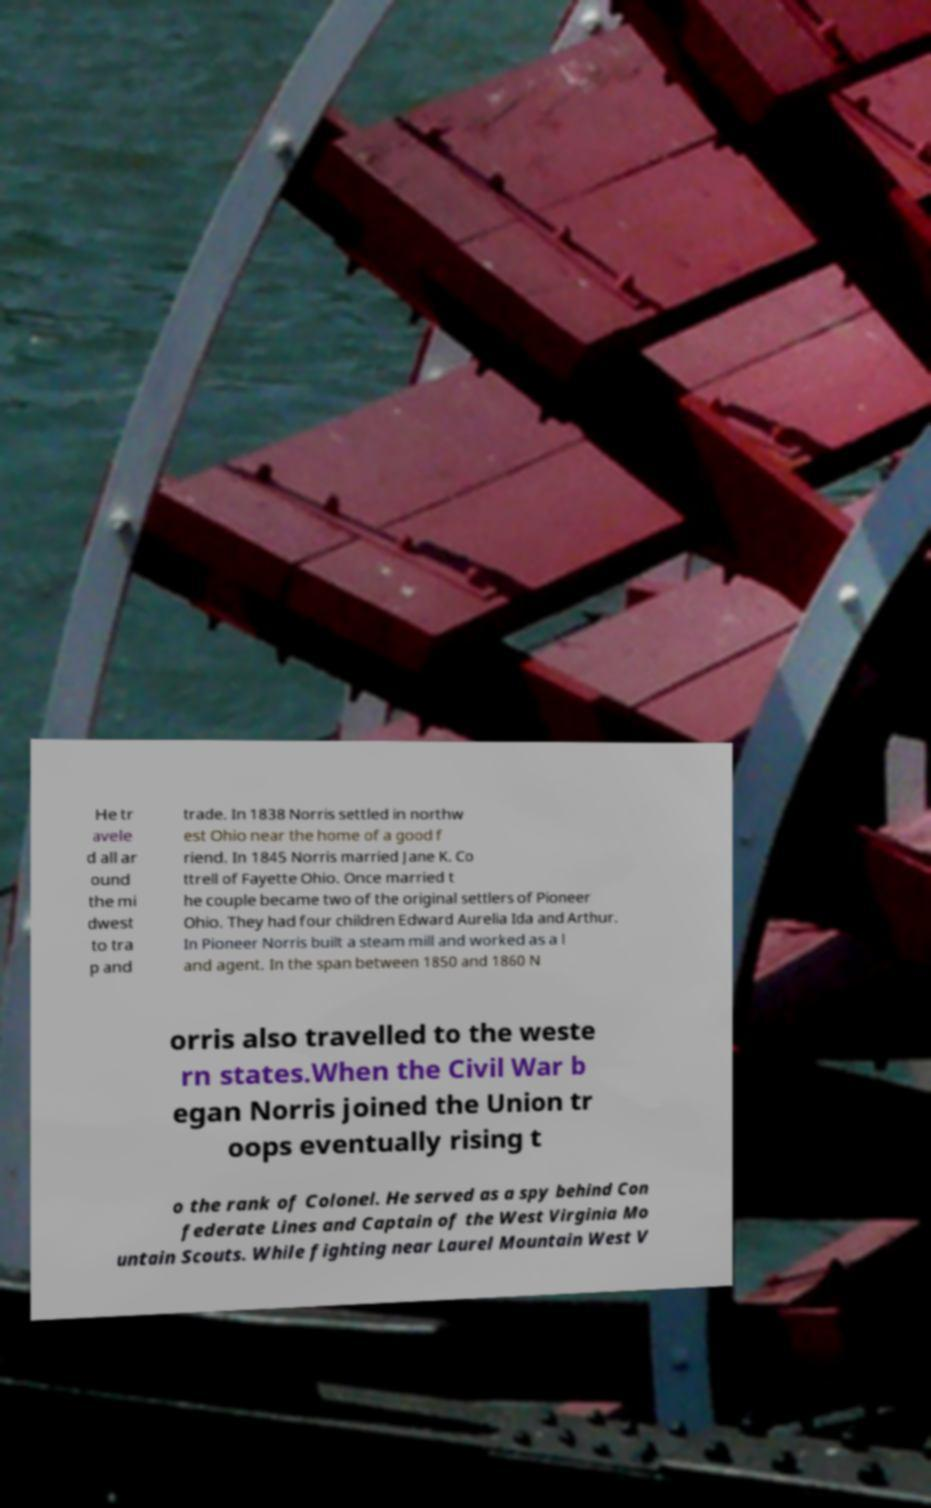Please read and relay the text visible in this image. What does it say? He tr avele d all ar ound the mi dwest to tra p and trade. In 1838 Norris settled in northw est Ohio near the home of a good f riend. In 1845 Norris married Jane K. Co ttrell of Fayette Ohio. Once married t he couple became two of the original settlers of Pioneer Ohio. They had four children Edward Aurelia Ida and Arthur. In Pioneer Norris built a steam mill and worked as a l and agent. In the span between 1850 and 1860 N orris also travelled to the weste rn states.When the Civil War b egan Norris joined the Union tr oops eventually rising t o the rank of Colonel. He served as a spy behind Con federate Lines and Captain of the West Virginia Mo untain Scouts. While fighting near Laurel Mountain West V 